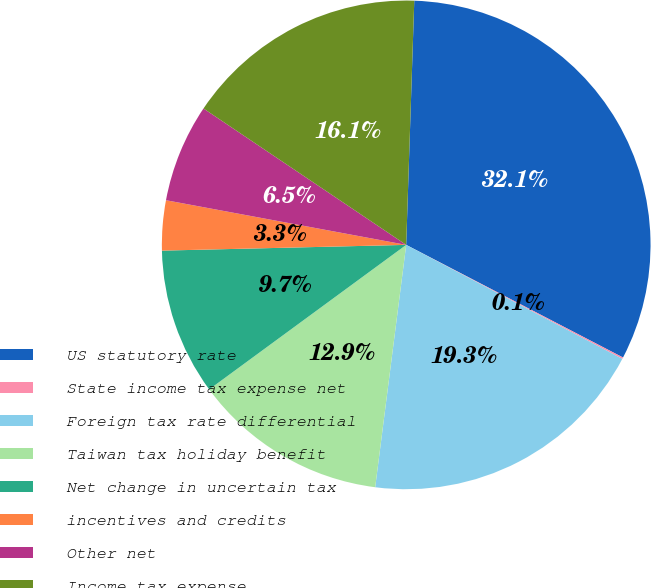Convert chart to OTSL. <chart><loc_0><loc_0><loc_500><loc_500><pie_chart><fcel>US statutory rate<fcel>State income tax expense net<fcel>Foreign tax rate differential<fcel>Taiwan tax holiday benefit<fcel>Net change in uncertain tax<fcel>incentives and credits<fcel>Other net<fcel>Income tax expense<nl><fcel>32.1%<fcel>0.1%<fcel>19.3%<fcel>12.9%<fcel>9.7%<fcel>3.3%<fcel>6.5%<fcel>16.1%<nl></chart> 